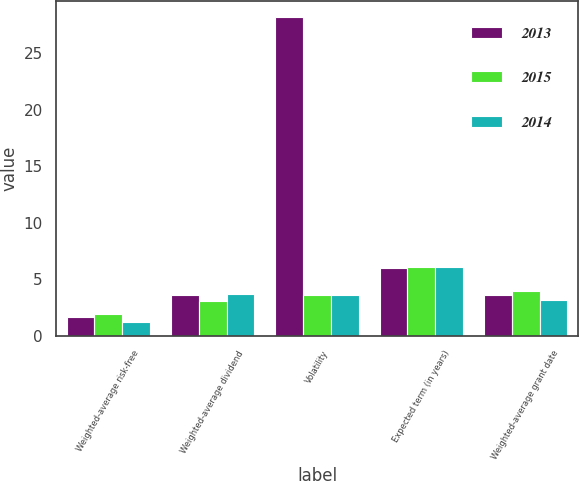<chart> <loc_0><loc_0><loc_500><loc_500><stacked_bar_chart><ecel><fcel>Weighted-average risk-free<fcel>Weighted-average dividend<fcel>Volatility<fcel>Expected term (in years)<fcel>Weighted-average grant date<nl><fcel>2013<fcel>1.7<fcel>3.6<fcel>28.2<fcel>6<fcel>3.58<nl><fcel>2015<fcel>1.9<fcel>3.1<fcel>3.6<fcel>6.09<fcel>3.95<nl><fcel>2014<fcel>1.2<fcel>3.7<fcel>3.6<fcel>6.09<fcel>3.2<nl></chart> 